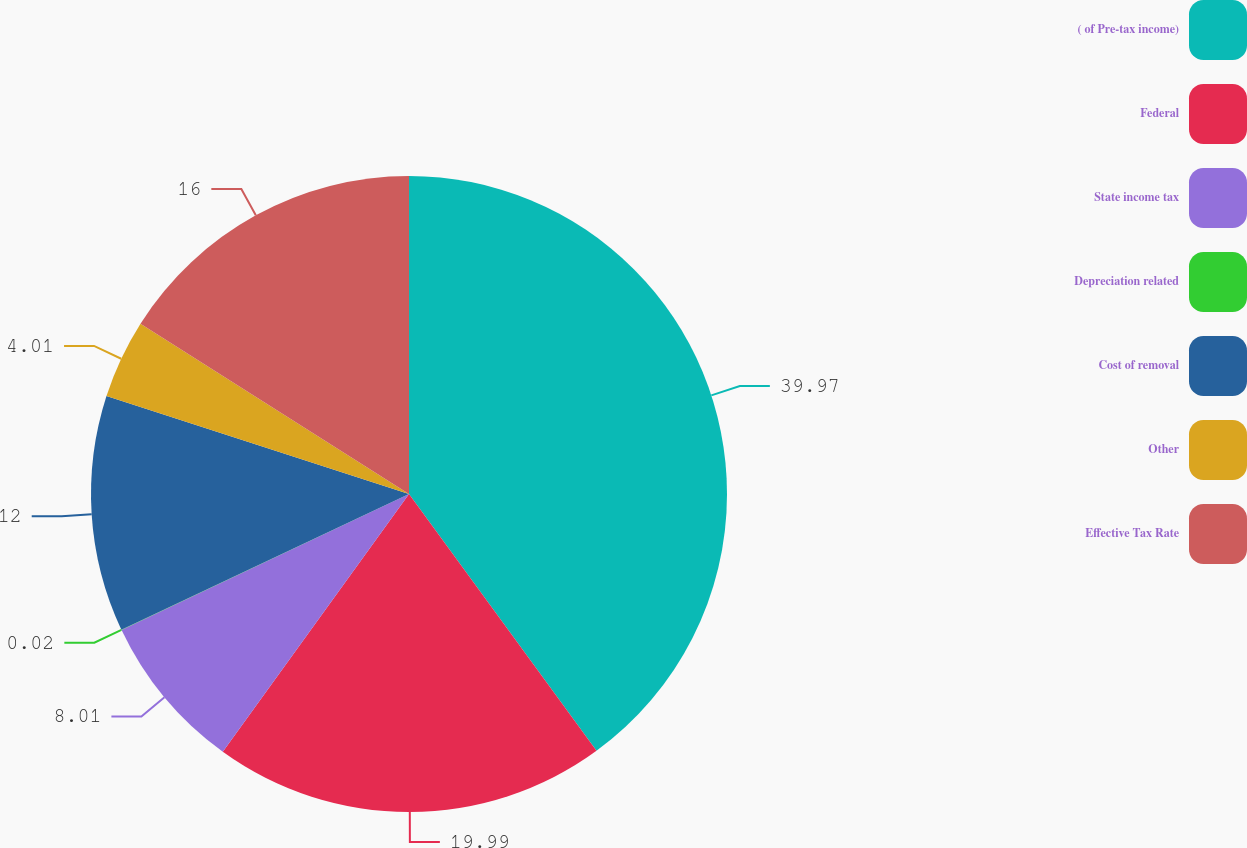Convert chart to OTSL. <chart><loc_0><loc_0><loc_500><loc_500><pie_chart><fcel>( of Pre-tax income)<fcel>Federal<fcel>State income tax<fcel>Depreciation related<fcel>Cost of removal<fcel>Other<fcel>Effective Tax Rate<nl><fcel>39.96%<fcel>19.99%<fcel>8.01%<fcel>0.02%<fcel>12.0%<fcel>4.01%<fcel>16.0%<nl></chart> 